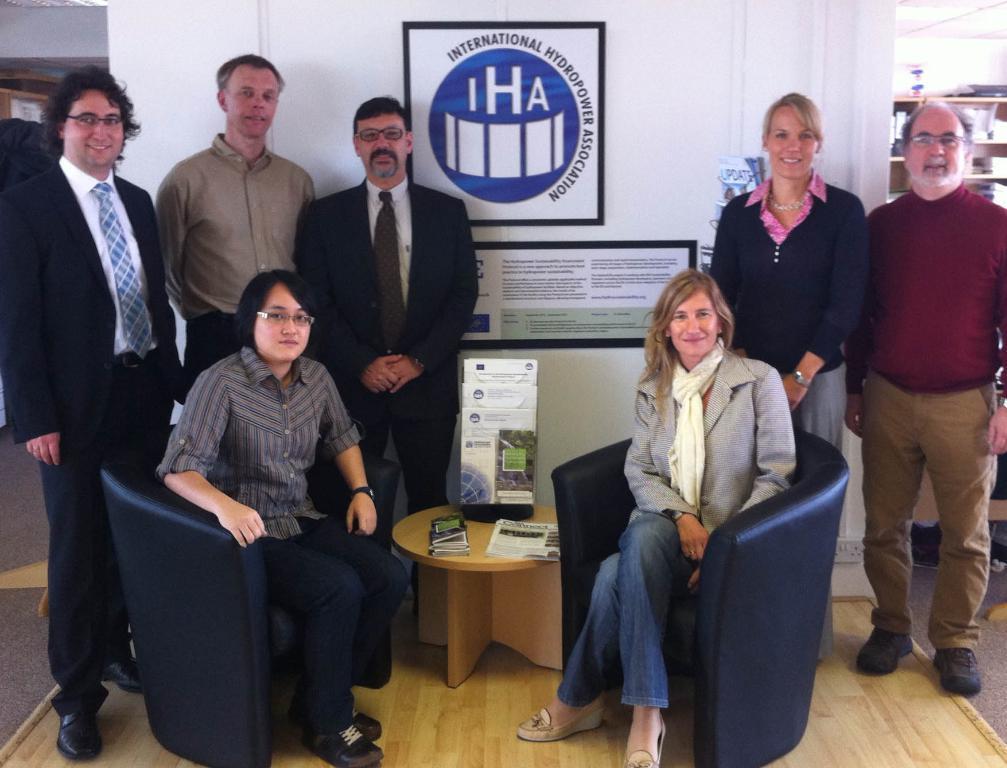How would you summarize this image in a sentence or two? In this picture we can see some people are standing and two persons are sitting on the chairs. This is the floor and there is a table. And on the background there is a wall. This is the poster. Even we can see a rack here. 